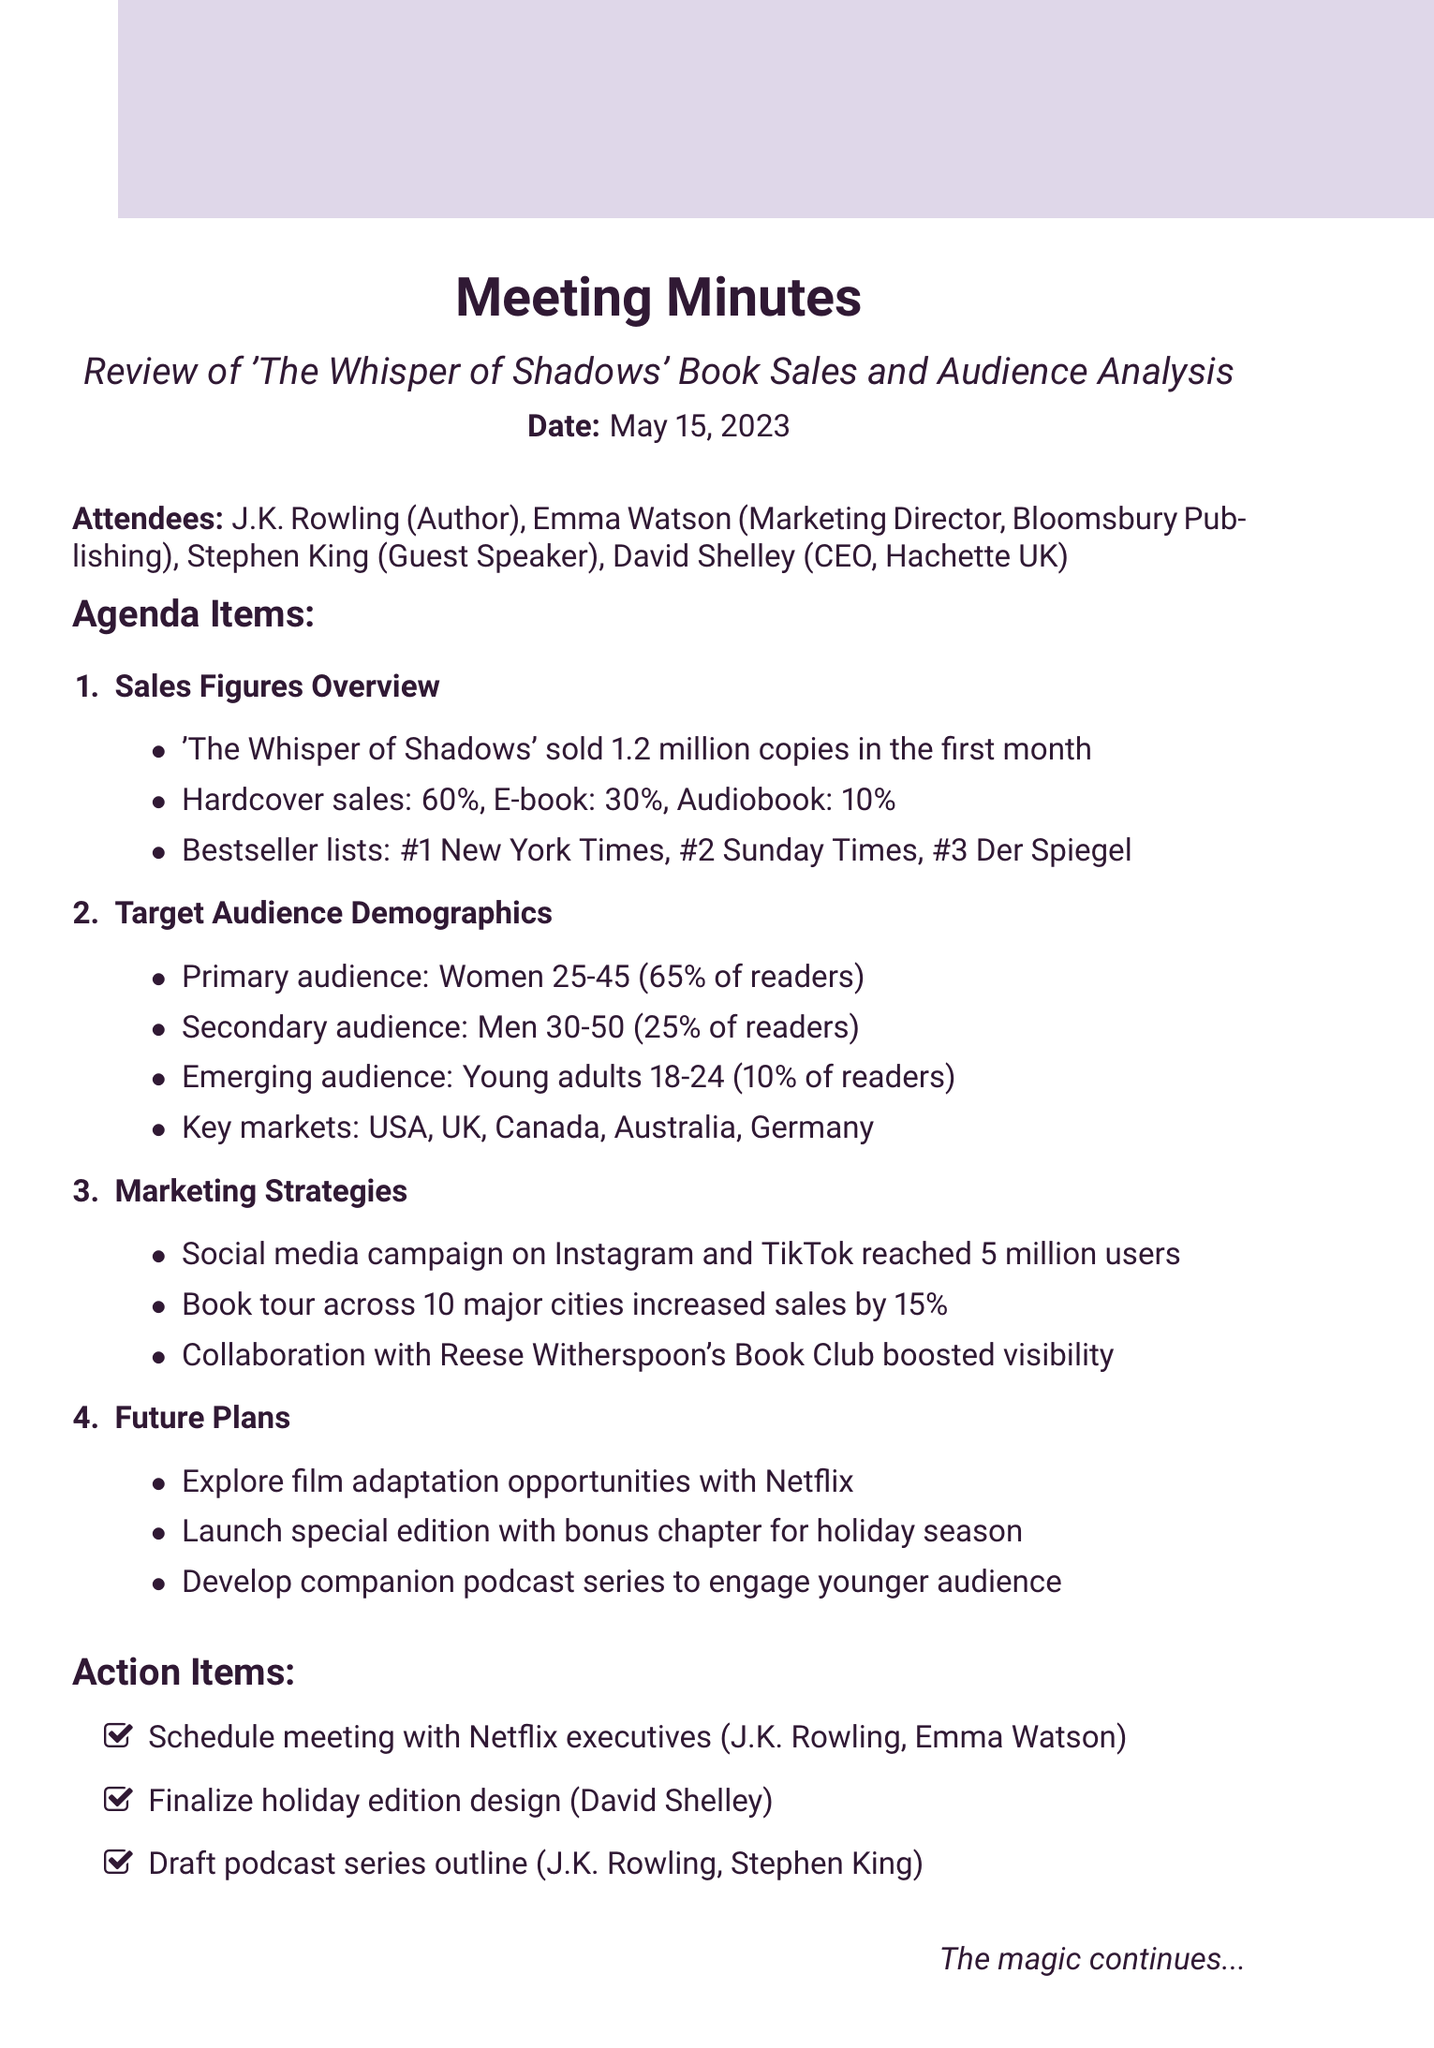What is the total number of copies sold in the first month? The document states that 'The Whisper of Shadows' sold 1.2 million copies in the first month.
Answer: 1.2 million What percentage of sales were hardcover? The document specifies that 60% of the sales were hardcover.
Answer: 60% Who is the author of 'The Whisper of Shadows'? J.K. Rowling is mentioned as the author in the attendees section of the document.
Answer: J.K. Rowling What is the primary audience for the book? The document describes the primary audience as women aged 25-45, accounting for 65% of readers.
Answer: Women 25-45 Which marketing strategy reached 5 million users? The document refers to a social media campaign on Instagram and TikTok that reached 5 million users.
Answer: Social media campaign How many major cities was the book tour held in? The document indicates that the book tour was across 10 major cities.
Answer: 10 What is one of the future plans mentioned in the document? The document lists several plans, one being to explore film adaptation opportunities with Netflix.
Answer: Film adaptation Who are the two people responsible for drafting the podcast series outline? The document states that J.K. Rowling and Stephen King are tasked with drafting the podcast series outline.
Answer: J.K. Rowling, Stephen King 